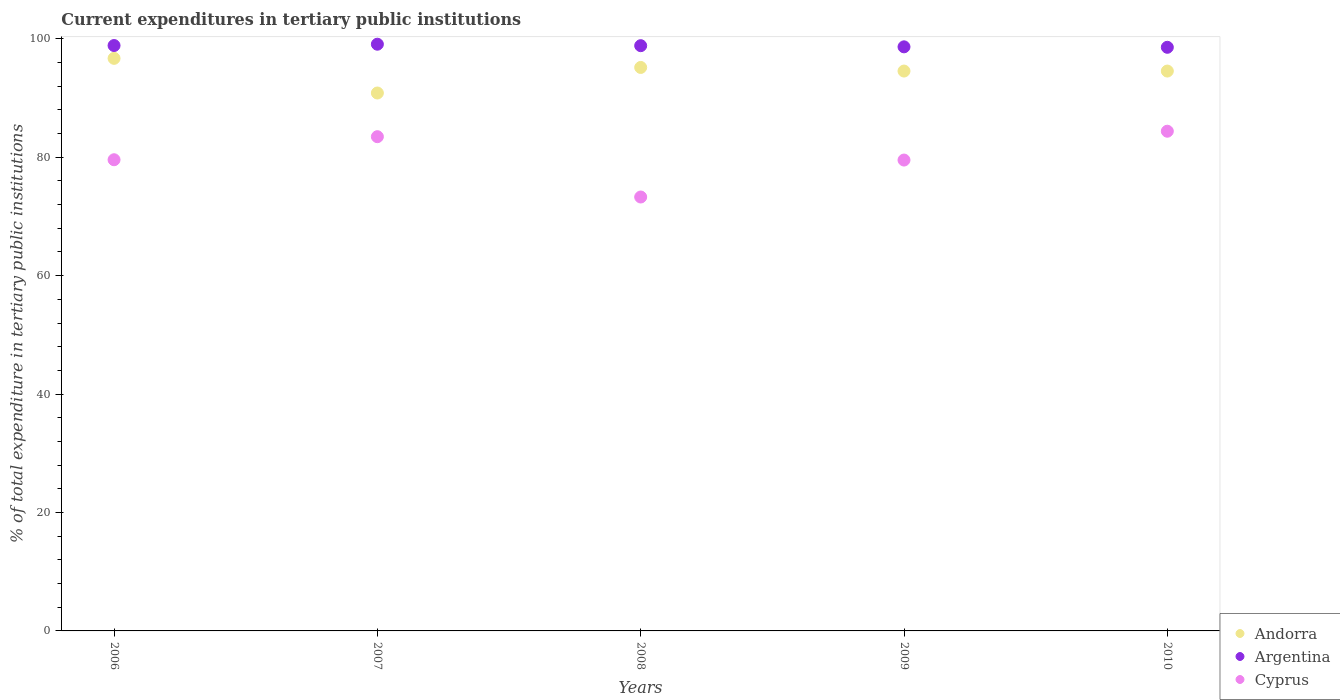How many different coloured dotlines are there?
Offer a terse response. 3. Is the number of dotlines equal to the number of legend labels?
Provide a succinct answer. Yes. What is the current expenditures in tertiary public institutions in Cyprus in 2007?
Provide a succinct answer. 83.47. Across all years, what is the maximum current expenditures in tertiary public institutions in Argentina?
Your answer should be compact. 99.08. Across all years, what is the minimum current expenditures in tertiary public institutions in Argentina?
Offer a very short reply. 98.56. In which year was the current expenditures in tertiary public institutions in Andorra maximum?
Provide a succinct answer. 2006. In which year was the current expenditures in tertiary public institutions in Argentina minimum?
Provide a short and direct response. 2010. What is the total current expenditures in tertiary public institutions in Cyprus in the graph?
Your answer should be very brief. 400.23. What is the difference between the current expenditures in tertiary public institutions in Cyprus in 2006 and that in 2010?
Provide a succinct answer. -4.82. What is the difference between the current expenditures in tertiary public institutions in Cyprus in 2010 and the current expenditures in tertiary public institutions in Argentina in 2008?
Keep it short and to the point. -14.45. What is the average current expenditures in tertiary public institutions in Andorra per year?
Make the answer very short. 94.36. In the year 2010, what is the difference between the current expenditures in tertiary public institutions in Argentina and current expenditures in tertiary public institutions in Cyprus?
Ensure brevity in your answer.  14.17. What is the ratio of the current expenditures in tertiary public institutions in Andorra in 2006 to that in 2008?
Provide a short and direct response. 1.02. Is the current expenditures in tertiary public institutions in Cyprus in 2008 less than that in 2009?
Provide a succinct answer. Yes. Is the difference between the current expenditures in tertiary public institutions in Argentina in 2008 and 2010 greater than the difference between the current expenditures in tertiary public institutions in Cyprus in 2008 and 2010?
Provide a succinct answer. Yes. What is the difference between the highest and the second highest current expenditures in tertiary public institutions in Andorra?
Your answer should be compact. 1.54. What is the difference between the highest and the lowest current expenditures in tertiary public institutions in Andorra?
Offer a very short reply. 5.85. In how many years, is the current expenditures in tertiary public institutions in Andorra greater than the average current expenditures in tertiary public institutions in Andorra taken over all years?
Your answer should be compact. 4. Is the sum of the current expenditures in tertiary public institutions in Argentina in 2008 and 2009 greater than the maximum current expenditures in tertiary public institutions in Cyprus across all years?
Make the answer very short. Yes. Is the current expenditures in tertiary public institutions in Argentina strictly greater than the current expenditures in tertiary public institutions in Andorra over the years?
Offer a terse response. Yes. Is the current expenditures in tertiary public institutions in Argentina strictly less than the current expenditures in tertiary public institutions in Andorra over the years?
Provide a short and direct response. No. How many dotlines are there?
Ensure brevity in your answer.  3. What is the difference between two consecutive major ticks on the Y-axis?
Provide a succinct answer. 20. Does the graph contain any zero values?
Your answer should be very brief. No. Does the graph contain grids?
Keep it short and to the point. No. Where does the legend appear in the graph?
Your answer should be compact. Bottom right. What is the title of the graph?
Ensure brevity in your answer.  Current expenditures in tertiary public institutions. Does "French Polynesia" appear as one of the legend labels in the graph?
Offer a very short reply. No. What is the label or title of the Y-axis?
Your answer should be very brief. % of total expenditure in tertiary public institutions. What is the % of total expenditure in tertiary public institutions in Andorra in 2006?
Make the answer very short. 96.7. What is the % of total expenditure in tertiary public institutions in Argentina in 2006?
Provide a short and direct response. 98.86. What is the % of total expenditure in tertiary public institutions in Cyprus in 2006?
Ensure brevity in your answer.  79.57. What is the % of total expenditure in tertiary public institutions of Andorra in 2007?
Your answer should be compact. 90.84. What is the % of total expenditure in tertiary public institutions in Argentina in 2007?
Give a very brief answer. 99.08. What is the % of total expenditure in tertiary public institutions in Cyprus in 2007?
Offer a very short reply. 83.47. What is the % of total expenditure in tertiary public institutions of Andorra in 2008?
Keep it short and to the point. 95.16. What is the % of total expenditure in tertiary public institutions of Argentina in 2008?
Give a very brief answer. 98.84. What is the % of total expenditure in tertiary public institutions of Cyprus in 2008?
Your answer should be compact. 73.28. What is the % of total expenditure in tertiary public institutions in Andorra in 2009?
Make the answer very short. 94.55. What is the % of total expenditure in tertiary public institutions of Argentina in 2009?
Your answer should be very brief. 98.64. What is the % of total expenditure in tertiary public institutions in Cyprus in 2009?
Your answer should be compact. 79.52. What is the % of total expenditure in tertiary public institutions in Andorra in 2010?
Your answer should be very brief. 94.55. What is the % of total expenditure in tertiary public institutions of Argentina in 2010?
Your response must be concise. 98.56. What is the % of total expenditure in tertiary public institutions of Cyprus in 2010?
Provide a short and direct response. 84.39. Across all years, what is the maximum % of total expenditure in tertiary public institutions in Andorra?
Keep it short and to the point. 96.7. Across all years, what is the maximum % of total expenditure in tertiary public institutions of Argentina?
Ensure brevity in your answer.  99.08. Across all years, what is the maximum % of total expenditure in tertiary public institutions of Cyprus?
Offer a very short reply. 84.39. Across all years, what is the minimum % of total expenditure in tertiary public institutions of Andorra?
Offer a terse response. 90.84. Across all years, what is the minimum % of total expenditure in tertiary public institutions of Argentina?
Offer a terse response. 98.56. Across all years, what is the minimum % of total expenditure in tertiary public institutions of Cyprus?
Your response must be concise. 73.28. What is the total % of total expenditure in tertiary public institutions of Andorra in the graph?
Your answer should be very brief. 471.8. What is the total % of total expenditure in tertiary public institutions in Argentina in the graph?
Provide a short and direct response. 493.99. What is the total % of total expenditure in tertiary public institutions of Cyprus in the graph?
Your answer should be compact. 400.23. What is the difference between the % of total expenditure in tertiary public institutions in Andorra in 2006 and that in 2007?
Keep it short and to the point. 5.85. What is the difference between the % of total expenditure in tertiary public institutions of Argentina in 2006 and that in 2007?
Keep it short and to the point. -0.22. What is the difference between the % of total expenditure in tertiary public institutions of Cyprus in 2006 and that in 2007?
Provide a short and direct response. -3.89. What is the difference between the % of total expenditure in tertiary public institutions of Andorra in 2006 and that in 2008?
Ensure brevity in your answer.  1.54. What is the difference between the % of total expenditure in tertiary public institutions in Argentina in 2006 and that in 2008?
Provide a short and direct response. 0.02. What is the difference between the % of total expenditure in tertiary public institutions of Cyprus in 2006 and that in 2008?
Provide a succinct answer. 6.29. What is the difference between the % of total expenditure in tertiary public institutions of Andorra in 2006 and that in 2009?
Your answer should be compact. 2.15. What is the difference between the % of total expenditure in tertiary public institutions of Argentina in 2006 and that in 2009?
Keep it short and to the point. 0.22. What is the difference between the % of total expenditure in tertiary public institutions in Cyprus in 2006 and that in 2009?
Offer a terse response. 0.05. What is the difference between the % of total expenditure in tertiary public institutions in Andorra in 2006 and that in 2010?
Give a very brief answer. 2.15. What is the difference between the % of total expenditure in tertiary public institutions in Argentina in 2006 and that in 2010?
Your answer should be compact. 0.3. What is the difference between the % of total expenditure in tertiary public institutions in Cyprus in 2006 and that in 2010?
Provide a short and direct response. -4.82. What is the difference between the % of total expenditure in tertiary public institutions of Andorra in 2007 and that in 2008?
Your answer should be compact. -4.32. What is the difference between the % of total expenditure in tertiary public institutions of Argentina in 2007 and that in 2008?
Provide a succinct answer. 0.25. What is the difference between the % of total expenditure in tertiary public institutions in Cyprus in 2007 and that in 2008?
Keep it short and to the point. 10.19. What is the difference between the % of total expenditure in tertiary public institutions in Andorra in 2007 and that in 2009?
Keep it short and to the point. -3.71. What is the difference between the % of total expenditure in tertiary public institutions of Argentina in 2007 and that in 2009?
Make the answer very short. 0.44. What is the difference between the % of total expenditure in tertiary public institutions in Cyprus in 2007 and that in 2009?
Your response must be concise. 3.95. What is the difference between the % of total expenditure in tertiary public institutions of Andorra in 2007 and that in 2010?
Provide a succinct answer. -3.71. What is the difference between the % of total expenditure in tertiary public institutions of Argentina in 2007 and that in 2010?
Keep it short and to the point. 0.52. What is the difference between the % of total expenditure in tertiary public institutions in Cyprus in 2007 and that in 2010?
Offer a very short reply. -0.92. What is the difference between the % of total expenditure in tertiary public institutions of Andorra in 2008 and that in 2009?
Your answer should be very brief. 0.61. What is the difference between the % of total expenditure in tertiary public institutions of Argentina in 2008 and that in 2009?
Your answer should be compact. 0.2. What is the difference between the % of total expenditure in tertiary public institutions of Cyprus in 2008 and that in 2009?
Provide a short and direct response. -6.24. What is the difference between the % of total expenditure in tertiary public institutions of Andorra in 2008 and that in 2010?
Your answer should be compact. 0.61. What is the difference between the % of total expenditure in tertiary public institutions of Argentina in 2008 and that in 2010?
Ensure brevity in your answer.  0.27. What is the difference between the % of total expenditure in tertiary public institutions in Cyprus in 2008 and that in 2010?
Offer a terse response. -11.11. What is the difference between the % of total expenditure in tertiary public institutions of Argentina in 2009 and that in 2010?
Offer a terse response. 0.08. What is the difference between the % of total expenditure in tertiary public institutions of Cyprus in 2009 and that in 2010?
Provide a short and direct response. -4.87. What is the difference between the % of total expenditure in tertiary public institutions in Andorra in 2006 and the % of total expenditure in tertiary public institutions in Argentina in 2007?
Provide a short and direct response. -2.39. What is the difference between the % of total expenditure in tertiary public institutions in Andorra in 2006 and the % of total expenditure in tertiary public institutions in Cyprus in 2007?
Make the answer very short. 13.23. What is the difference between the % of total expenditure in tertiary public institutions in Argentina in 2006 and the % of total expenditure in tertiary public institutions in Cyprus in 2007?
Provide a short and direct response. 15.39. What is the difference between the % of total expenditure in tertiary public institutions in Andorra in 2006 and the % of total expenditure in tertiary public institutions in Argentina in 2008?
Your answer should be very brief. -2.14. What is the difference between the % of total expenditure in tertiary public institutions in Andorra in 2006 and the % of total expenditure in tertiary public institutions in Cyprus in 2008?
Offer a terse response. 23.42. What is the difference between the % of total expenditure in tertiary public institutions of Argentina in 2006 and the % of total expenditure in tertiary public institutions of Cyprus in 2008?
Ensure brevity in your answer.  25.58. What is the difference between the % of total expenditure in tertiary public institutions of Andorra in 2006 and the % of total expenditure in tertiary public institutions of Argentina in 2009?
Your answer should be compact. -1.94. What is the difference between the % of total expenditure in tertiary public institutions in Andorra in 2006 and the % of total expenditure in tertiary public institutions in Cyprus in 2009?
Offer a terse response. 17.17. What is the difference between the % of total expenditure in tertiary public institutions in Argentina in 2006 and the % of total expenditure in tertiary public institutions in Cyprus in 2009?
Make the answer very short. 19.34. What is the difference between the % of total expenditure in tertiary public institutions in Andorra in 2006 and the % of total expenditure in tertiary public institutions in Argentina in 2010?
Your answer should be very brief. -1.87. What is the difference between the % of total expenditure in tertiary public institutions in Andorra in 2006 and the % of total expenditure in tertiary public institutions in Cyprus in 2010?
Keep it short and to the point. 12.31. What is the difference between the % of total expenditure in tertiary public institutions in Argentina in 2006 and the % of total expenditure in tertiary public institutions in Cyprus in 2010?
Your response must be concise. 14.47. What is the difference between the % of total expenditure in tertiary public institutions in Andorra in 2007 and the % of total expenditure in tertiary public institutions in Argentina in 2008?
Your answer should be very brief. -7.99. What is the difference between the % of total expenditure in tertiary public institutions of Andorra in 2007 and the % of total expenditure in tertiary public institutions of Cyprus in 2008?
Offer a very short reply. 17.56. What is the difference between the % of total expenditure in tertiary public institutions in Argentina in 2007 and the % of total expenditure in tertiary public institutions in Cyprus in 2008?
Provide a succinct answer. 25.8. What is the difference between the % of total expenditure in tertiary public institutions of Andorra in 2007 and the % of total expenditure in tertiary public institutions of Argentina in 2009?
Offer a very short reply. -7.8. What is the difference between the % of total expenditure in tertiary public institutions in Andorra in 2007 and the % of total expenditure in tertiary public institutions in Cyprus in 2009?
Your response must be concise. 11.32. What is the difference between the % of total expenditure in tertiary public institutions in Argentina in 2007 and the % of total expenditure in tertiary public institutions in Cyprus in 2009?
Your answer should be compact. 19.56. What is the difference between the % of total expenditure in tertiary public institutions of Andorra in 2007 and the % of total expenditure in tertiary public institutions of Argentina in 2010?
Offer a terse response. -7.72. What is the difference between the % of total expenditure in tertiary public institutions in Andorra in 2007 and the % of total expenditure in tertiary public institutions in Cyprus in 2010?
Make the answer very short. 6.45. What is the difference between the % of total expenditure in tertiary public institutions of Argentina in 2007 and the % of total expenditure in tertiary public institutions of Cyprus in 2010?
Keep it short and to the point. 14.69. What is the difference between the % of total expenditure in tertiary public institutions of Andorra in 2008 and the % of total expenditure in tertiary public institutions of Argentina in 2009?
Offer a terse response. -3.48. What is the difference between the % of total expenditure in tertiary public institutions in Andorra in 2008 and the % of total expenditure in tertiary public institutions in Cyprus in 2009?
Your answer should be compact. 15.64. What is the difference between the % of total expenditure in tertiary public institutions in Argentina in 2008 and the % of total expenditure in tertiary public institutions in Cyprus in 2009?
Your answer should be very brief. 19.32. What is the difference between the % of total expenditure in tertiary public institutions in Andorra in 2008 and the % of total expenditure in tertiary public institutions in Argentina in 2010?
Offer a terse response. -3.4. What is the difference between the % of total expenditure in tertiary public institutions of Andorra in 2008 and the % of total expenditure in tertiary public institutions of Cyprus in 2010?
Ensure brevity in your answer.  10.77. What is the difference between the % of total expenditure in tertiary public institutions in Argentina in 2008 and the % of total expenditure in tertiary public institutions in Cyprus in 2010?
Give a very brief answer. 14.45. What is the difference between the % of total expenditure in tertiary public institutions in Andorra in 2009 and the % of total expenditure in tertiary public institutions in Argentina in 2010?
Give a very brief answer. -4.01. What is the difference between the % of total expenditure in tertiary public institutions of Andorra in 2009 and the % of total expenditure in tertiary public institutions of Cyprus in 2010?
Keep it short and to the point. 10.16. What is the difference between the % of total expenditure in tertiary public institutions of Argentina in 2009 and the % of total expenditure in tertiary public institutions of Cyprus in 2010?
Offer a very short reply. 14.25. What is the average % of total expenditure in tertiary public institutions of Andorra per year?
Make the answer very short. 94.36. What is the average % of total expenditure in tertiary public institutions of Argentina per year?
Your answer should be compact. 98.8. What is the average % of total expenditure in tertiary public institutions of Cyprus per year?
Provide a short and direct response. 80.05. In the year 2006, what is the difference between the % of total expenditure in tertiary public institutions in Andorra and % of total expenditure in tertiary public institutions in Argentina?
Your answer should be compact. -2.17. In the year 2006, what is the difference between the % of total expenditure in tertiary public institutions in Andorra and % of total expenditure in tertiary public institutions in Cyprus?
Your response must be concise. 17.12. In the year 2006, what is the difference between the % of total expenditure in tertiary public institutions in Argentina and % of total expenditure in tertiary public institutions in Cyprus?
Your response must be concise. 19.29. In the year 2007, what is the difference between the % of total expenditure in tertiary public institutions in Andorra and % of total expenditure in tertiary public institutions in Argentina?
Provide a succinct answer. -8.24. In the year 2007, what is the difference between the % of total expenditure in tertiary public institutions in Andorra and % of total expenditure in tertiary public institutions in Cyprus?
Make the answer very short. 7.38. In the year 2007, what is the difference between the % of total expenditure in tertiary public institutions of Argentina and % of total expenditure in tertiary public institutions of Cyprus?
Your answer should be compact. 15.62. In the year 2008, what is the difference between the % of total expenditure in tertiary public institutions in Andorra and % of total expenditure in tertiary public institutions in Argentina?
Make the answer very short. -3.68. In the year 2008, what is the difference between the % of total expenditure in tertiary public institutions of Andorra and % of total expenditure in tertiary public institutions of Cyprus?
Make the answer very short. 21.88. In the year 2008, what is the difference between the % of total expenditure in tertiary public institutions in Argentina and % of total expenditure in tertiary public institutions in Cyprus?
Give a very brief answer. 25.56. In the year 2009, what is the difference between the % of total expenditure in tertiary public institutions in Andorra and % of total expenditure in tertiary public institutions in Argentina?
Ensure brevity in your answer.  -4.09. In the year 2009, what is the difference between the % of total expenditure in tertiary public institutions of Andorra and % of total expenditure in tertiary public institutions of Cyprus?
Make the answer very short. 15.03. In the year 2009, what is the difference between the % of total expenditure in tertiary public institutions of Argentina and % of total expenditure in tertiary public institutions of Cyprus?
Provide a succinct answer. 19.12. In the year 2010, what is the difference between the % of total expenditure in tertiary public institutions of Andorra and % of total expenditure in tertiary public institutions of Argentina?
Ensure brevity in your answer.  -4.01. In the year 2010, what is the difference between the % of total expenditure in tertiary public institutions of Andorra and % of total expenditure in tertiary public institutions of Cyprus?
Ensure brevity in your answer.  10.16. In the year 2010, what is the difference between the % of total expenditure in tertiary public institutions of Argentina and % of total expenditure in tertiary public institutions of Cyprus?
Offer a very short reply. 14.17. What is the ratio of the % of total expenditure in tertiary public institutions in Andorra in 2006 to that in 2007?
Offer a very short reply. 1.06. What is the ratio of the % of total expenditure in tertiary public institutions of Cyprus in 2006 to that in 2007?
Offer a terse response. 0.95. What is the ratio of the % of total expenditure in tertiary public institutions in Andorra in 2006 to that in 2008?
Give a very brief answer. 1.02. What is the ratio of the % of total expenditure in tertiary public institutions of Argentina in 2006 to that in 2008?
Keep it short and to the point. 1. What is the ratio of the % of total expenditure in tertiary public institutions in Cyprus in 2006 to that in 2008?
Offer a very short reply. 1.09. What is the ratio of the % of total expenditure in tertiary public institutions of Andorra in 2006 to that in 2009?
Your response must be concise. 1.02. What is the ratio of the % of total expenditure in tertiary public institutions of Argentina in 2006 to that in 2009?
Provide a short and direct response. 1. What is the ratio of the % of total expenditure in tertiary public institutions of Andorra in 2006 to that in 2010?
Provide a short and direct response. 1.02. What is the ratio of the % of total expenditure in tertiary public institutions in Argentina in 2006 to that in 2010?
Make the answer very short. 1. What is the ratio of the % of total expenditure in tertiary public institutions of Cyprus in 2006 to that in 2010?
Your answer should be compact. 0.94. What is the ratio of the % of total expenditure in tertiary public institutions in Andorra in 2007 to that in 2008?
Make the answer very short. 0.95. What is the ratio of the % of total expenditure in tertiary public institutions of Argentina in 2007 to that in 2008?
Your answer should be compact. 1. What is the ratio of the % of total expenditure in tertiary public institutions of Cyprus in 2007 to that in 2008?
Make the answer very short. 1.14. What is the ratio of the % of total expenditure in tertiary public institutions in Andorra in 2007 to that in 2009?
Your answer should be compact. 0.96. What is the ratio of the % of total expenditure in tertiary public institutions in Cyprus in 2007 to that in 2009?
Ensure brevity in your answer.  1.05. What is the ratio of the % of total expenditure in tertiary public institutions of Andorra in 2007 to that in 2010?
Keep it short and to the point. 0.96. What is the ratio of the % of total expenditure in tertiary public institutions in Cyprus in 2007 to that in 2010?
Keep it short and to the point. 0.99. What is the ratio of the % of total expenditure in tertiary public institutions of Cyprus in 2008 to that in 2009?
Give a very brief answer. 0.92. What is the ratio of the % of total expenditure in tertiary public institutions in Andorra in 2008 to that in 2010?
Your answer should be compact. 1.01. What is the ratio of the % of total expenditure in tertiary public institutions of Cyprus in 2008 to that in 2010?
Provide a succinct answer. 0.87. What is the ratio of the % of total expenditure in tertiary public institutions in Andorra in 2009 to that in 2010?
Offer a terse response. 1. What is the ratio of the % of total expenditure in tertiary public institutions of Cyprus in 2009 to that in 2010?
Give a very brief answer. 0.94. What is the difference between the highest and the second highest % of total expenditure in tertiary public institutions of Andorra?
Your answer should be compact. 1.54. What is the difference between the highest and the second highest % of total expenditure in tertiary public institutions in Argentina?
Offer a terse response. 0.22. What is the difference between the highest and the second highest % of total expenditure in tertiary public institutions in Cyprus?
Your answer should be very brief. 0.92. What is the difference between the highest and the lowest % of total expenditure in tertiary public institutions in Andorra?
Ensure brevity in your answer.  5.85. What is the difference between the highest and the lowest % of total expenditure in tertiary public institutions in Argentina?
Offer a very short reply. 0.52. What is the difference between the highest and the lowest % of total expenditure in tertiary public institutions of Cyprus?
Offer a terse response. 11.11. 